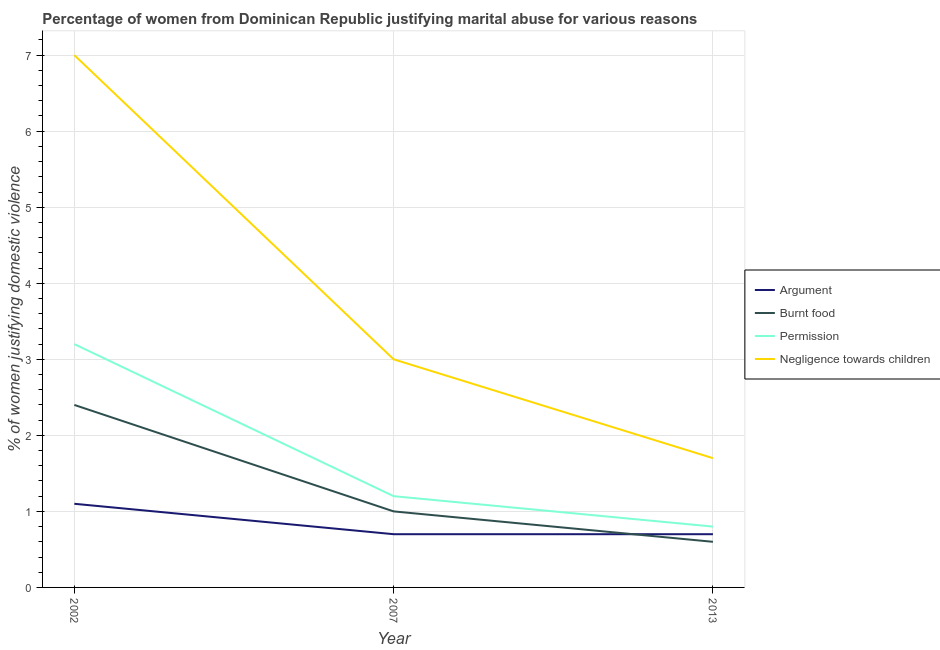How many different coloured lines are there?
Your response must be concise. 4. Across all years, what is the maximum percentage of women justifying abuse for going without permission?
Make the answer very short. 3.2. In which year was the percentage of women justifying abuse in the case of an argument maximum?
Make the answer very short. 2002. In which year was the percentage of women justifying abuse for burning food minimum?
Ensure brevity in your answer.  2013. What is the total percentage of women justifying abuse for showing negligence towards children in the graph?
Offer a very short reply. 11.7. What is the difference between the percentage of women justifying abuse for burning food in 2002 and that in 2007?
Make the answer very short. 1.4. What is the average percentage of women justifying abuse in the case of an argument per year?
Your response must be concise. 0.83. In the year 2013, what is the difference between the percentage of women justifying abuse in the case of an argument and percentage of women justifying abuse for showing negligence towards children?
Make the answer very short. -1. What is the ratio of the percentage of women justifying abuse in the case of an argument in 2007 to that in 2013?
Offer a terse response. 1. Is the percentage of women justifying abuse for going without permission in 2007 less than that in 2013?
Your response must be concise. No. What is the difference between the highest and the lowest percentage of women justifying abuse for going without permission?
Provide a short and direct response. 2.4. In how many years, is the percentage of women justifying abuse in the case of an argument greater than the average percentage of women justifying abuse in the case of an argument taken over all years?
Provide a succinct answer. 1. Is it the case that in every year, the sum of the percentage of women justifying abuse in the case of an argument and percentage of women justifying abuse for burning food is greater than the percentage of women justifying abuse for going without permission?
Offer a very short reply. Yes. Is the percentage of women justifying abuse for showing negligence towards children strictly greater than the percentage of women justifying abuse in the case of an argument over the years?
Your answer should be compact. Yes. Is the percentage of women justifying abuse in the case of an argument strictly less than the percentage of women justifying abuse for showing negligence towards children over the years?
Your answer should be very brief. Yes. How many lines are there?
Your response must be concise. 4. How many years are there in the graph?
Ensure brevity in your answer.  3. What is the difference between two consecutive major ticks on the Y-axis?
Offer a very short reply. 1. Where does the legend appear in the graph?
Offer a terse response. Center right. How many legend labels are there?
Keep it short and to the point. 4. What is the title of the graph?
Ensure brevity in your answer.  Percentage of women from Dominican Republic justifying marital abuse for various reasons. What is the label or title of the X-axis?
Keep it short and to the point. Year. What is the label or title of the Y-axis?
Your answer should be compact. % of women justifying domestic violence. What is the % of women justifying domestic violence of Burnt food in 2002?
Provide a succinct answer. 2.4. What is the % of women justifying domestic violence in Negligence towards children in 2002?
Give a very brief answer. 7. What is the % of women justifying domestic violence in Permission in 2007?
Offer a terse response. 1.2. What is the % of women justifying domestic violence of Negligence towards children in 2007?
Provide a succinct answer. 3. What is the % of women justifying domestic violence of Burnt food in 2013?
Offer a very short reply. 0.6. What is the % of women justifying domestic violence of Permission in 2013?
Give a very brief answer. 0.8. What is the % of women justifying domestic violence in Negligence towards children in 2013?
Keep it short and to the point. 1.7. Across all years, what is the maximum % of women justifying domestic violence of Argument?
Offer a very short reply. 1.1. Across all years, what is the maximum % of women justifying domestic violence of Permission?
Your answer should be compact. 3.2. Across all years, what is the minimum % of women justifying domestic violence in Argument?
Your response must be concise. 0.7. Across all years, what is the minimum % of women justifying domestic violence in Permission?
Ensure brevity in your answer.  0.8. Across all years, what is the minimum % of women justifying domestic violence in Negligence towards children?
Keep it short and to the point. 1.7. What is the total % of women justifying domestic violence in Argument in the graph?
Provide a succinct answer. 2.5. What is the total % of women justifying domestic violence in Permission in the graph?
Provide a succinct answer. 5.2. What is the difference between the % of women justifying domestic violence in Burnt food in 2002 and that in 2013?
Your answer should be compact. 1.8. What is the difference between the % of women justifying domestic violence of Permission in 2002 and that in 2013?
Your answer should be very brief. 2.4. What is the difference between the % of women justifying domestic violence of Negligence towards children in 2002 and that in 2013?
Make the answer very short. 5.3. What is the difference between the % of women justifying domestic violence in Argument in 2007 and that in 2013?
Offer a very short reply. 0. What is the difference between the % of women justifying domestic violence in Permission in 2007 and that in 2013?
Provide a succinct answer. 0.4. What is the difference between the % of women justifying domestic violence in Negligence towards children in 2007 and that in 2013?
Make the answer very short. 1.3. What is the difference between the % of women justifying domestic violence in Argument in 2002 and the % of women justifying domestic violence in Permission in 2007?
Your answer should be compact. -0.1. What is the difference between the % of women justifying domestic violence of Argument in 2002 and the % of women justifying domestic violence of Negligence towards children in 2007?
Your answer should be compact. -1.9. What is the difference between the % of women justifying domestic violence of Burnt food in 2002 and the % of women justifying domestic violence of Permission in 2007?
Offer a terse response. 1.2. What is the difference between the % of women justifying domestic violence in Burnt food in 2002 and the % of women justifying domestic violence in Negligence towards children in 2007?
Keep it short and to the point. -0.6. What is the difference between the % of women justifying domestic violence of Permission in 2002 and the % of women justifying domestic violence of Negligence towards children in 2007?
Your response must be concise. 0.2. What is the difference between the % of women justifying domestic violence of Argument in 2002 and the % of women justifying domestic violence of Negligence towards children in 2013?
Offer a terse response. -0.6. What is the difference between the % of women justifying domestic violence of Burnt food in 2002 and the % of women justifying domestic violence of Negligence towards children in 2013?
Ensure brevity in your answer.  0.7. What is the difference between the % of women justifying domestic violence in Argument in 2007 and the % of women justifying domestic violence in Burnt food in 2013?
Your answer should be compact. 0.1. What is the difference between the % of women justifying domestic violence of Argument in 2007 and the % of women justifying domestic violence of Permission in 2013?
Give a very brief answer. -0.1. What is the average % of women justifying domestic violence of Argument per year?
Offer a terse response. 0.83. What is the average % of women justifying domestic violence in Permission per year?
Your response must be concise. 1.73. What is the average % of women justifying domestic violence in Negligence towards children per year?
Keep it short and to the point. 3.9. In the year 2002, what is the difference between the % of women justifying domestic violence of Argument and % of women justifying domestic violence of Burnt food?
Your response must be concise. -1.3. In the year 2002, what is the difference between the % of women justifying domestic violence in Argument and % of women justifying domestic violence in Permission?
Keep it short and to the point. -2.1. In the year 2007, what is the difference between the % of women justifying domestic violence in Argument and % of women justifying domestic violence in Negligence towards children?
Provide a succinct answer. -2.3. In the year 2007, what is the difference between the % of women justifying domestic violence in Burnt food and % of women justifying domestic violence in Permission?
Ensure brevity in your answer.  -0.2. In the year 2007, what is the difference between the % of women justifying domestic violence of Burnt food and % of women justifying domestic violence of Negligence towards children?
Ensure brevity in your answer.  -2. In the year 2013, what is the difference between the % of women justifying domestic violence in Argument and % of women justifying domestic violence in Burnt food?
Provide a short and direct response. 0.1. In the year 2013, what is the difference between the % of women justifying domestic violence of Argument and % of women justifying domestic violence of Negligence towards children?
Your answer should be very brief. -1. In the year 2013, what is the difference between the % of women justifying domestic violence in Permission and % of women justifying domestic violence in Negligence towards children?
Provide a succinct answer. -0.9. What is the ratio of the % of women justifying domestic violence of Argument in 2002 to that in 2007?
Your answer should be very brief. 1.57. What is the ratio of the % of women justifying domestic violence in Permission in 2002 to that in 2007?
Make the answer very short. 2.67. What is the ratio of the % of women justifying domestic violence of Negligence towards children in 2002 to that in 2007?
Ensure brevity in your answer.  2.33. What is the ratio of the % of women justifying domestic violence in Argument in 2002 to that in 2013?
Your response must be concise. 1.57. What is the ratio of the % of women justifying domestic violence in Negligence towards children in 2002 to that in 2013?
Make the answer very short. 4.12. What is the ratio of the % of women justifying domestic violence of Argument in 2007 to that in 2013?
Your answer should be compact. 1. What is the ratio of the % of women justifying domestic violence in Burnt food in 2007 to that in 2013?
Ensure brevity in your answer.  1.67. What is the ratio of the % of women justifying domestic violence of Negligence towards children in 2007 to that in 2013?
Ensure brevity in your answer.  1.76. What is the difference between the highest and the second highest % of women justifying domestic violence in Burnt food?
Give a very brief answer. 1.4. What is the difference between the highest and the lowest % of women justifying domestic violence in Permission?
Your response must be concise. 2.4. What is the difference between the highest and the lowest % of women justifying domestic violence in Negligence towards children?
Offer a terse response. 5.3. 